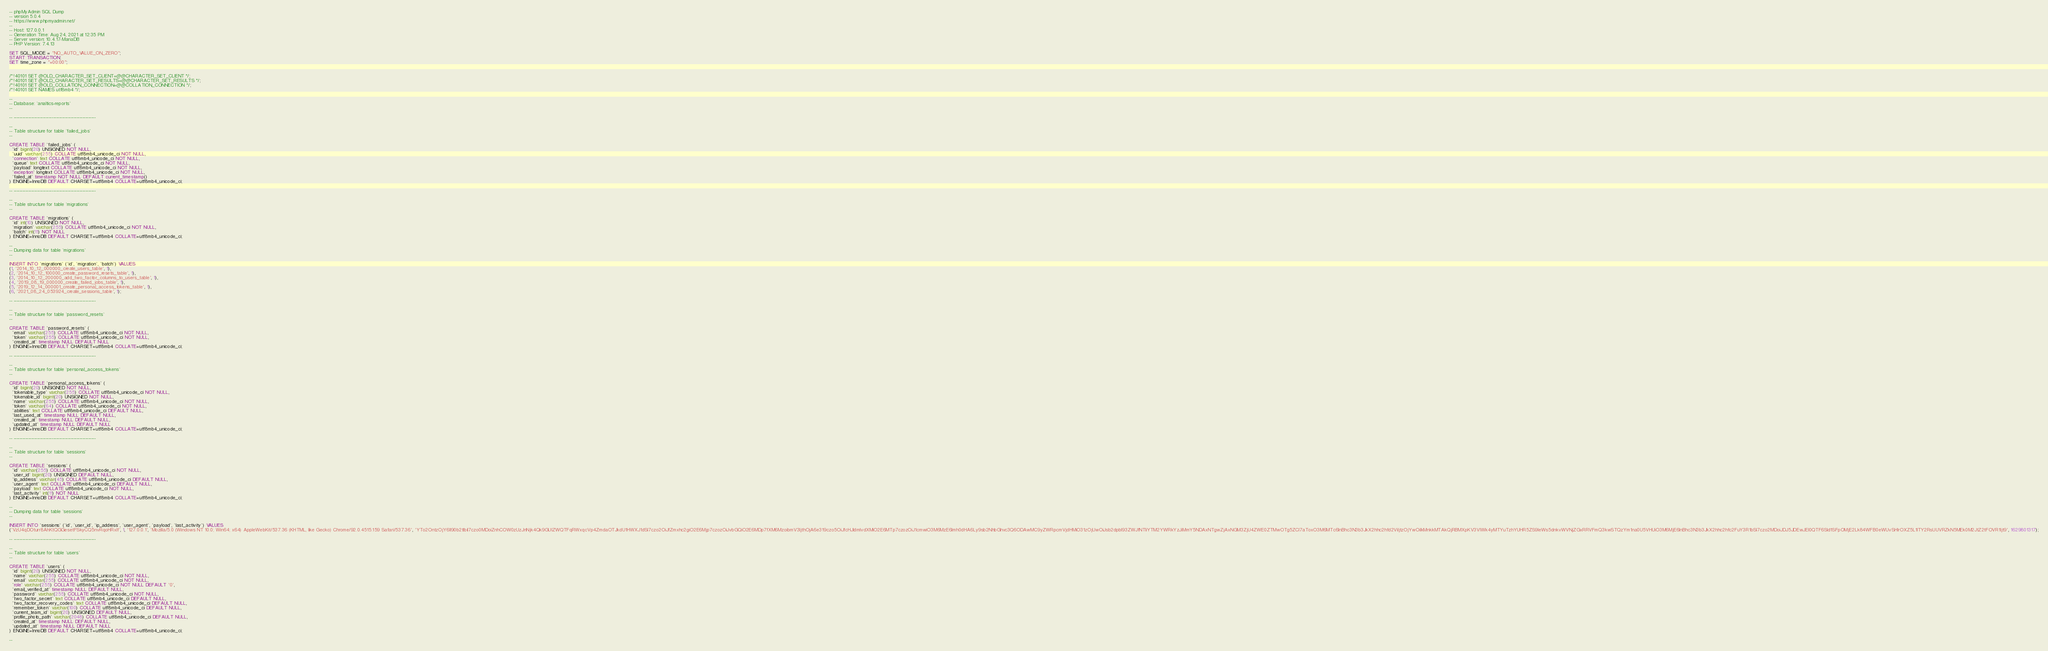<code> <loc_0><loc_0><loc_500><loc_500><_SQL_>-- phpMyAdmin SQL Dump
-- version 5.0.4
-- https://www.phpmyadmin.net/
--
-- Host: 127.0.0.1
-- Generation Time: Aug 24, 2021 at 12:35 PM
-- Server version: 10.4.17-MariaDB
-- PHP Version: 7.4.13

SET SQL_MODE = "NO_AUTO_VALUE_ON_ZERO";
START TRANSACTION;
SET time_zone = "+00:00";


/*!40101 SET @OLD_CHARACTER_SET_CLIENT=@@CHARACTER_SET_CLIENT */;
/*!40101 SET @OLD_CHARACTER_SET_RESULTS=@@CHARACTER_SET_RESULTS */;
/*!40101 SET @OLD_COLLATION_CONNECTION=@@COLLATION_CONNECTION */;
/*!40101 SET NAMES utf8mb4 */;

--
-- Database: `analtics-reports`
--

-- --------------------------------------------------------

--
-- Table structure for table `failed_jobs`
--

CREATE TABLE `failed_jobs` (
  `id` bigint(20) UNSIGNED NOT NULL,
  `uuid` varchar(255) COLLATE utf8mb4_unicode_ci NOT NULL,
  `connection` text COLLATE utf8mb4_unicode_ci NOT NULL,
  `queue` text COLLATE utf8mb4_unicode_ci NOT NULL,
  `payload` longtext COLLATE utf8mb4_unicode_ci NOT NULL,
  `exception` longtext COLLATE utf8mb4_unicode_ci NOT NULL,
  `failed_at` timestamp NOT NULL DEFAULT current_timestamp()
) ENGINE=InnoDB DEFAULT CHARSET=utf8mb4 COLLATE=utf8mb4_unicode_ci;

-- --------------------------------------------------------

--
-- Table structure for table `migrations`
--

CREATE TABLE `migrations` (
  `id` int(10) UNSIGNED NOT NULL,
  `migration` varchar(255) COLLATE utf8mb4_unicode_ci NOT NULL,
  `batch` int(11) NOT NULL
) ENGINE=InnoDB DEFAULT CHARSET=utf8mb4 COLLATE=utf8mb4_unicode_ci;

--
-- Dumping data for table `migrations`
--

INSERT INTO `migrations` (`id`, `migration`, `batch`) VALUES
(1, '2014_10_12_000000_create_users_table', 1),
(2, '2014_10_12_100000_create_password_resets_table', 1),
(3, '2014_10_12_200000_add_two_factor_columns_to_users_table', 1),
(4, '2019_08_19_000000_create_failed_jobs_table', 1),
(5, '2019_12_14_000001_create_personal_access_tokens_table', 1),
(6, '2021_08_24_053924_create_sessions_table', 1);

-- --------------------------------------------------------

--
-- Table structure for table `password_resets`
--

CREATE TABLE `password_resets` (
  `email` varchar(255) COLLATE utf8mb4_unicode_ci NOT NULL,
  `token` varchar(255) COLLATE utf8mb4_unicode_ci NOT NULL,
  `created_at` timestamp NULL DEFAULT NULL
) ENGINE=InnoDB DEFAULT CHARSET=utf8mb4 COLLATE=utf8mb4_unicode_ci;

-- --------------------------------------------------------

--
-- Table structure for table `personal_access_tokens`
--

CREATE TABLE `personal_access_tokens` (
  `id` bigint(20) UNSIGNED NOT NULL,
  `tokenable_type` varchar(255) COLLATE utf8mb4_unicode_ci NOT NULL,
  `tokenable_id` bigint(20) UNSIGNED NOT NULL,
  `name` varchar(255) COLLATE utf8mb4_unicode_ci NOT NULL,
  `token` varchar(64) COLLATE utf8mb4_unicode_ci NOT NULL,
  `abilities` text COLLATE utf8mb4_unicode_ci DEFAULT NULL,
  `last_used_at` timestamp NULL DEFAULT NULL,
  `created_at` timestamp NULL DEFAULT NULL,
  `updated_at` timestamp NULL DEFAULT NULL
) ENGINE=InnoDB DEFAULT CHARSET=utf8mb4 COLLATE=utf8mb4_unicode_ci;

-- --------------------------------------------------------

--
-- Table structure for table `sessions`
--

CREATE TABLE `sessions` (
  `id` varchar(255) COLLATE utf8mb4_unicode_ci NOT NULL,
  `user_id` bigint(20) UNSIGNED DEFAULT NULL,
  `ip_address` varchar(45) COLLATE utf8mb4_unicode_ci DEFAULT NULL,
  `user_agent` text COLLATE utf8mb4_unicode_ci DEFAULT NULL,
  `payload` text COLLATE utf8mb4_unicode_ci NOT NULL,
  `last_activity` int(11) NOT NULL
) ENGINE=InnoDB DEFAULT CHARSET=utf8mb4 COLLATE=utf8mb4_unicode_ci;

--
-- Dumping data for table `sessions`
--

INSERT INTO `sessions` (`id`, `user_id`, `ip_address`, `user_agent`, `payload`, `last_activity`) VALUES
('VzU4qDOturr8AhKtQGGesetFSkyCQ5nvRqoHRxIf', 1, '127.0.0.1', 'Mozilla/5.0 (Windows NT 10.0; Win64; x64) AppleWebKit/537.36 (KHTML, like Gecko) Chrome/92.0.4515.159 Safari/537.36', 'YTo2OntzOjY6Il90b2tlbiI7czo0MDoiZnhCOW0zUzJnNjk4Qk9GUlZWQTFqRWxqcVp4ZmdaOTJkdU1HWXJ1dSI7czo2OiJfZmxhc2giO2E6Mjp7czozOiJvbGQiO2E6MDp7fXM6MzoibmV3IjthOjA6e319czo5OiJfcHJldmlvdXMiO2E6MTp7czozOiJ1cmwiO3M6MzE6Imh0dHA6Ly9sb2NhbGhvc3Q6ODAwMC9yZWRpcmVjdHMiO31zOjUwOiJsb2dpbl93ZWJfNTliYTM2YWRkYzJiMmY5NDAxNTgwZjAxNGM3ZjU4ZWE0ZTMwOTg5ZCI7aToxO3M6MTc6InBhc3N3b3JkX2hhc2hfd2ViIjtzOjYwOiIkMnkkMTAkQjRBMXpKV3VIWk4yMTYuTzhYUHR5ZS9IeWs5dnkvWVNjZGxRRVFmQ3kwSTQzYm1na0U5VHUiO3M6MjE6InBhc3N3b3JkX2hhc2hfc2FuY3R1bSI7czo2MDoiJDJ5JDEwJEI0QTF6Sld1SFpOMjE2Lk84WFB0eWUvSHlrOXZ5L1lTY2RsUUVRZkN5MEk0M2JtZ2tFOVR1Ijt9', 1629801317);

-- --------------------------------------------------------

--
-- Table structure for table `users`
--

CREATE TABLE `users` (
  `id` bigint(20) UNSIGNED NOT NULL,
  `name` varchar(255) COLLATE utf8mb4_unicode_ci NOT NULL,
  `email` varchar(255) COLLATE utf8mb4_unicode_ci NOT NULL,
  `role` varchar(255) COLLATE utf8mb4_unicode_ci NOT NULL DEFAULT '0',
  `email_verified_at` timestamp NULL DEFAULT NULL,
  `password` varchar(255) COLLATE utf8mb4_unicode_ci NOT NULL,
  `two_factor_secret` text COLLATE utf8mb4_unicode_ci DEFAULT NULL,
  `two_factor_recovery_codes` text COLLATE utf8mb4_unicode_ci DEFAULT NULL,
  `remember_token` varchar(100) COLLATE utf8mb4_unicode_ci DEFAULT NULL,
  `current_team_id` bigint(20) UNSIGNED DEFAULT NULL,
  `profile_photo_path` varchar(2048) COLLATE utf8mb4_unicode_ci DEFAULT NULL,
  `created_at` timestamp NULL DEFAULT NULL,
  `updated_at` timestamp NULL DEFAULT NULL
) ENGINE=InnoDB DEFAULT CHARSET=utf8mb4 COLLATE=utf8mb4_unicode_ci;

--</code> 